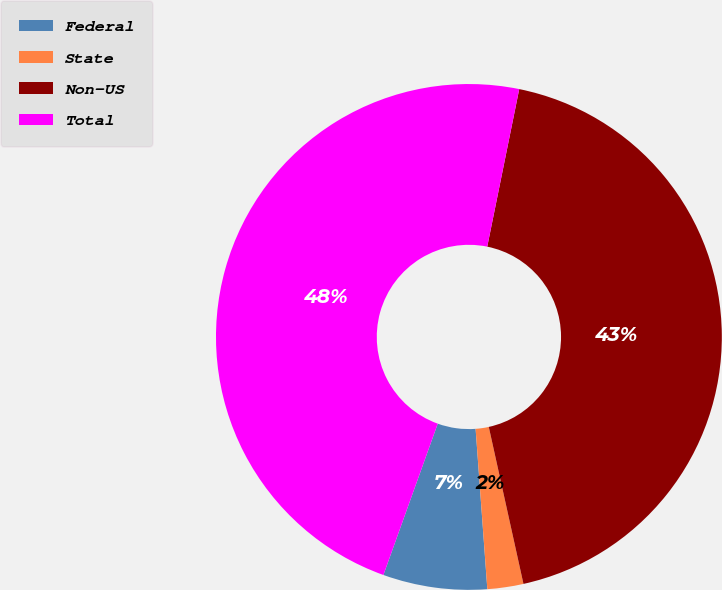<chart> <loc_0><loc_0><loc_500><loc_500><pie_chart><fcel>Federal<fcel>State<fcel>Non-US<fcel>Total<nl><fcel>6.65%<fcel>2.3%<fcel>43.35%<fcel>47.7%<nl></chart> 